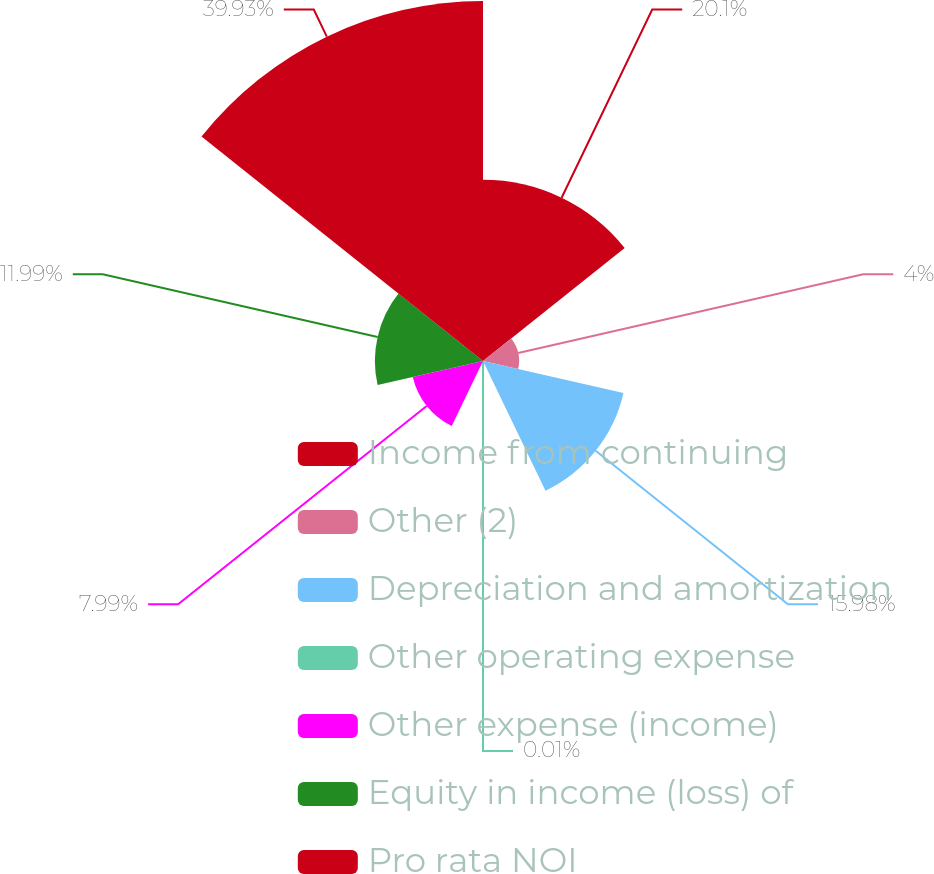Convert chart to OTSL. <chart><loc_0><loc_0><loc_500><loc_500><pie_chart><fcel>Income from continuing<fcel>Other (2)<fcel>Depreciation and amortization<fcel>Other operating expense<fcel>Other expense (income)<fcel>Equity in income (loss) of<fcel>Pro rata NOI<nl><fcel>20.1%<fcel>4.0%<fcel>15.98%<fcel>0.01%<fcel>7.99%<fcel>11.99%<fcel>39.93%<nl></chart> 